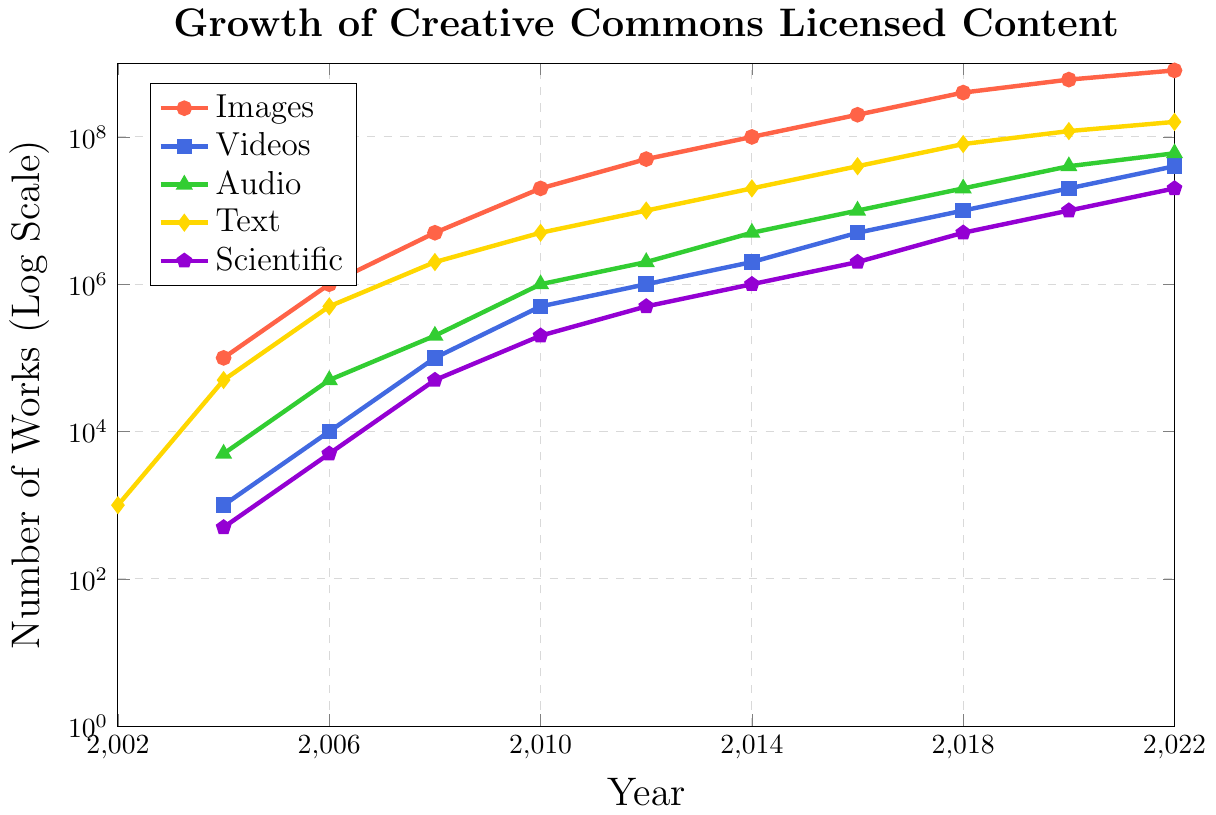What media type had the highest number of works in 2022? By looking at the height of the lines for each media type in 2022, the 'Images' line is the highest.
Answer: Images How did the number of Images change from 2006 to 2010? In 2006, the number of Images was 1,000,000. By 2010, it increased to 20,000,000. The change is 20,000,000 - 1,000,000 = 19,000,000.
Answer: Increased by 19,000,000 Which media type saw the smallest increase from 2002 to 2006? From the coordinates at 2002 and 2006, 'Audio' went from 0 to 50,000 which is an increase of 50,000. 'Videos' went from 0 to 10,000, increasing by 10,000. 'Scientific' went from 0 to 5,000, increasing by 5,000. 'Text' increased by 499,000 (from 1,000 to 500,000). Thus, Scientific had the smallest increase of 5,000.
Answer: Scientific What is the sum of the number of works for all media types in 2018? Add the numbers of works for each media type in 2018: 400,000,000 (Images) + 10,000,000 (Videos) + 20,000,000 (Audio) + 80,000,000 (Text) + 5,000,000 (Scientific) = 515,000,000 works.
Answer: 515,000,000 works Between which years did 'Text' content experience its first doubling? The 'Text' line at 2002 was 1,000, and by 2004 it reached 50,000, more than doubling. So, it's between 2002 and 2004.
Answer: 2002 to 2004 Compare the growth rate of 'Videos' and 'Scientific' content from 2010 to 2014. Which increased more? In 2010, 'Videos' had 500,000 and by 2014 it increased to 2,000,000. The increase is 1,500,000. 'Scientific' went from 200,000 to 1,000,000, increasing by 800,000. Both increased, but Videos increased more (1,500,000 vs 800,000).
Answer: Videos What is the trend shown for 'Audio' content? The 'Audio' line is continuously going up indicating an upward trend in the number of Audio works from 2002 to 2022.
Answer: Upward trend By what factor did 'Videos' increase from 2006 to 2022? In 2006, Videos were at 10,000, and in 2022, they were at 40,000,000. The factor is 40,000,000 / 10,000 = 4,000.
Answer: 4,000 